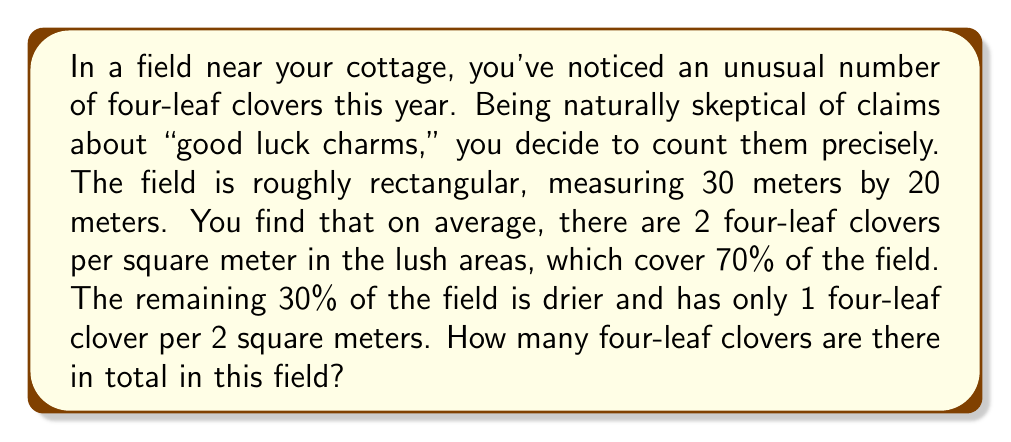Give your solution to this math problem. Let's approach this step-by-step:

1. Calculate the total area of the field:
   $$ \text{Total Area} = 30\text{ m} \times 20\text{ m} = 600\text{ m}^2 $$

2. Calculate the area of the lush part (70% of the field):
   $$ \text{Lush Area} = 70\% \times 600\text{ m}^2 = 0.7 \times 600\text{ m}^2 = 420\text{ m}^2 $$

3. Calculate the area of the dry part (30% of the field):
   $$ \text{Dry Area} = 30\% \times 600\text{ m}^2 = 0.3 \times 600\text{ m}^2 = 180\text{ m}^2 $$

4. Calculate the number of four-leaf clovers in the lush area:
   $$ \text{Clovers in Lush Area} = 420\text{ m}^2 \times 2\text{ clovers/m}^2 = 840\text{ clovers} $$

5. Calculate the number of four-leaf clovers in the dry area:
   $$ \text{Clovers in Dry Area} = 180\text{ m}^2 \times \frac{1\text{ clover}}{2\text{ m}^2} = 90\text{ clovers} $$

6. Sum up the total number of four-leaf clovers:
   $$ \text{Total Clovers} = 840 + 90 = 930\text{ clovers} $$
Answer: There are 930 four-leaf clovers in the field. 